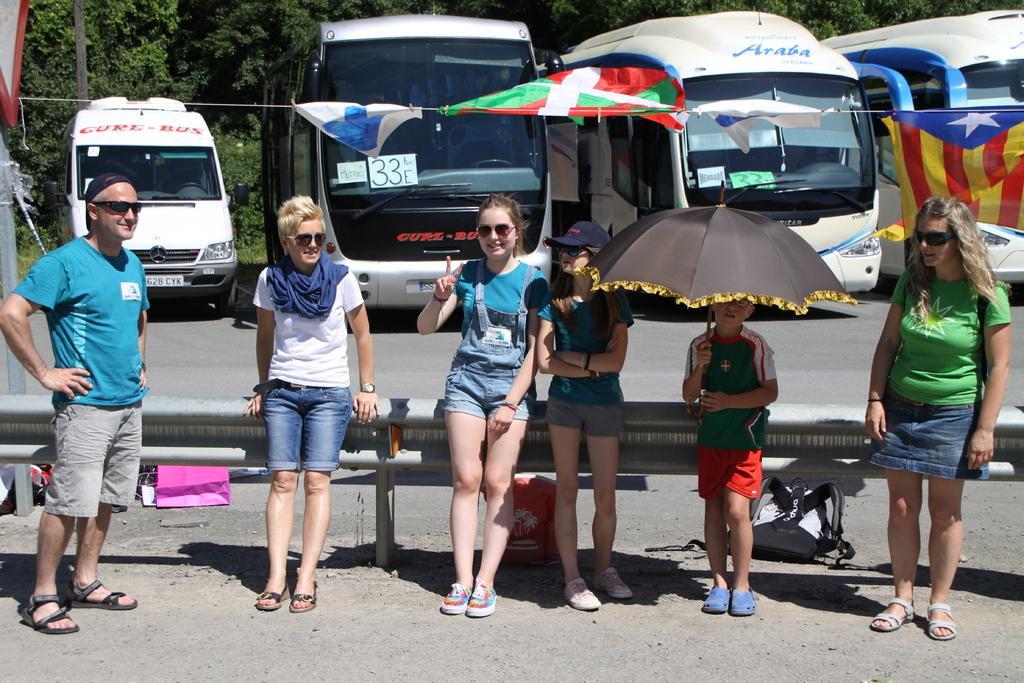Please provide a concise description of this image. In the image there are a group of people standing in the front and behind them there are four vehicles parked beside the road and behind the vehicles there are many trees. 